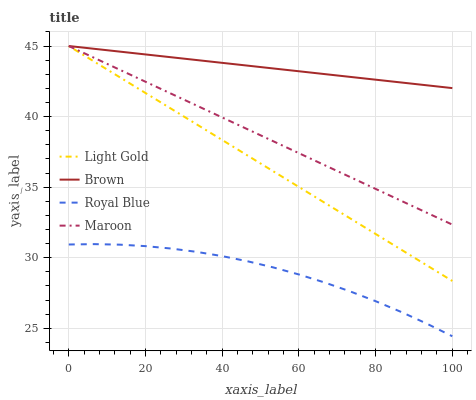Does Royal Blue have the minimum area under the curve?
Answer yes or no. Yes. Does Brown have the maximum area under the curve?
Answer yes or no. Yes. Does Light Gold have the minimum area under the curve?
Answer yes or no. No. Does Light Gold have the maximum area under the curve?
Answer yes or no. No. Is Maroon the smoothest?
Answer yes or no. Yes. Is Royal Blue the roughest?
Answer yes or no. Yes. Is Light Gold the smoothest?
Answer yes or no. No. Is Light Gold the roughest?
Answer yes or no. No. Does Royal Blue have the lowest value?
Answer yes or no. Yes. Does Light Gold have the lowest value?
Answer yes or no. No. Does Maroon have the highest value?
Answer yes or no. Yes. Does Royal Blue have the highest value?
Answer yes or no. No. Is Royal Blue less than Brown?
Answer yes or no. Yes. Is Brown greater than Royal Blue?
Answer yes or no. Yes. Does Maroon intersect Light Gold?
Answer yes or no. Yes. Is Maroon less than Light Gold?
Answer yes or no. No. Is Maroon greater than Light Gold?
Answer yes or no. No. Does Royal Blue intersect Brown?
Answer yes or no. No. 